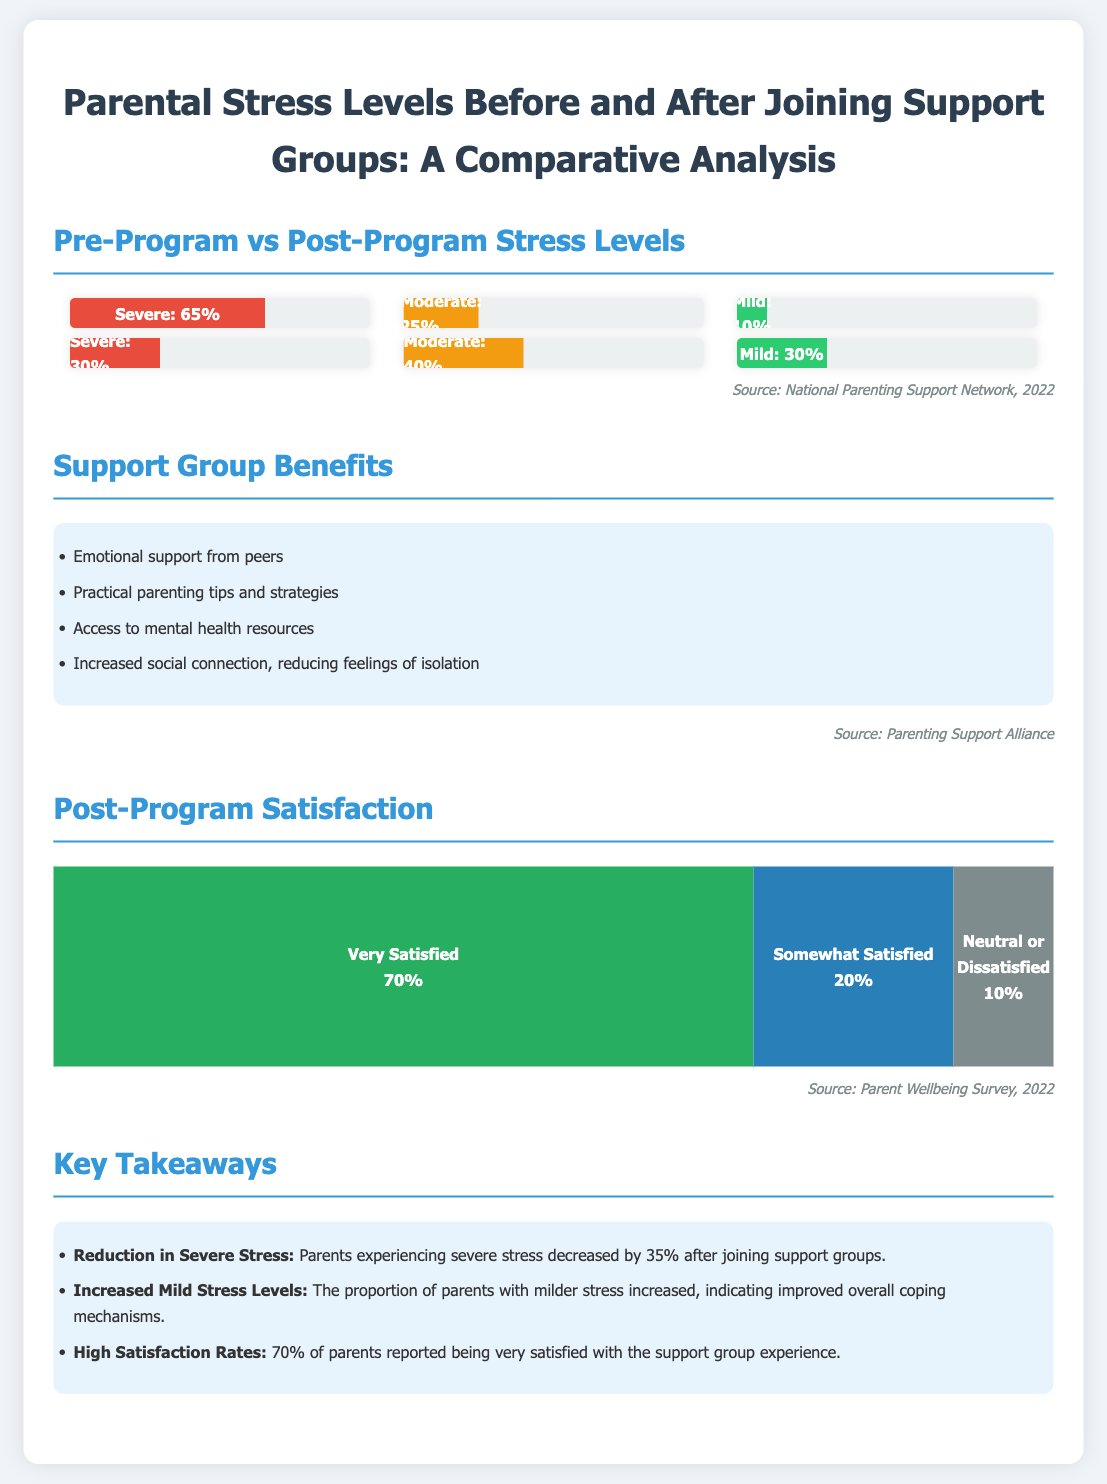What percentage of parents experienced severe stress before joining support groups? The document states that 65% of parents experienced severe stress before joining the support groups.
Answer: 65% What percentage of parents were very satisfied after joining support groups? It shows that 70% of parents reported being very satisfied with the support group experience after joining.
Answer: 70% What change occurred in the percentage of parents experiencing mild stress after joining support groups? The proportion of parents experiencing mild stress increased from 10% to 30%, indicating better coping mechanisms.
Answer: Increased What category of stress had the highest percentage after joining support groups? The document indicates that moderate stress had the highest percentage at 40% after joining the support groups.
Answer: Moderate What was one of the benefits of joining a support group mentioned in the infographic? The infographic lists "emotional support from peers" as one of the benefits of joining a support group.
Answer: Emotional support from peers What was the percentage of parents reporting neutral or dissatisfied feelings post-program? According to the satisfaction results, 10% of parents reported being neutral or dissatisfied.
Answer: 10% What was the decrease in the percentage of parents experiencing severe stress after joining support groups? The document mentions a 35% decrease in parents experiencing severe stress after joining the support groups.
Answer: 35% What design element is used to represent different satisfaction levels visually in the infographic? The infographic uses a segmented bar chart to represent different levels of post-program satisfaction.
Answer: Segmented bar chart 